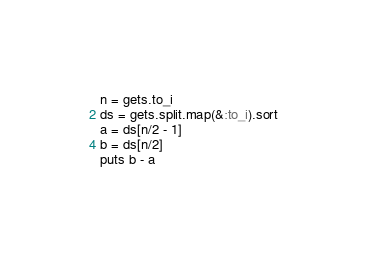Convert code to text. <code><loc_0><loc_0><loc_500><loc_500><_Ruby_>n = gets.to_i
ds = gets.split.map(&:to_i).sort
a = ds[n/2 - 1]
b = ds[n/2]
puts b - a
</code> 